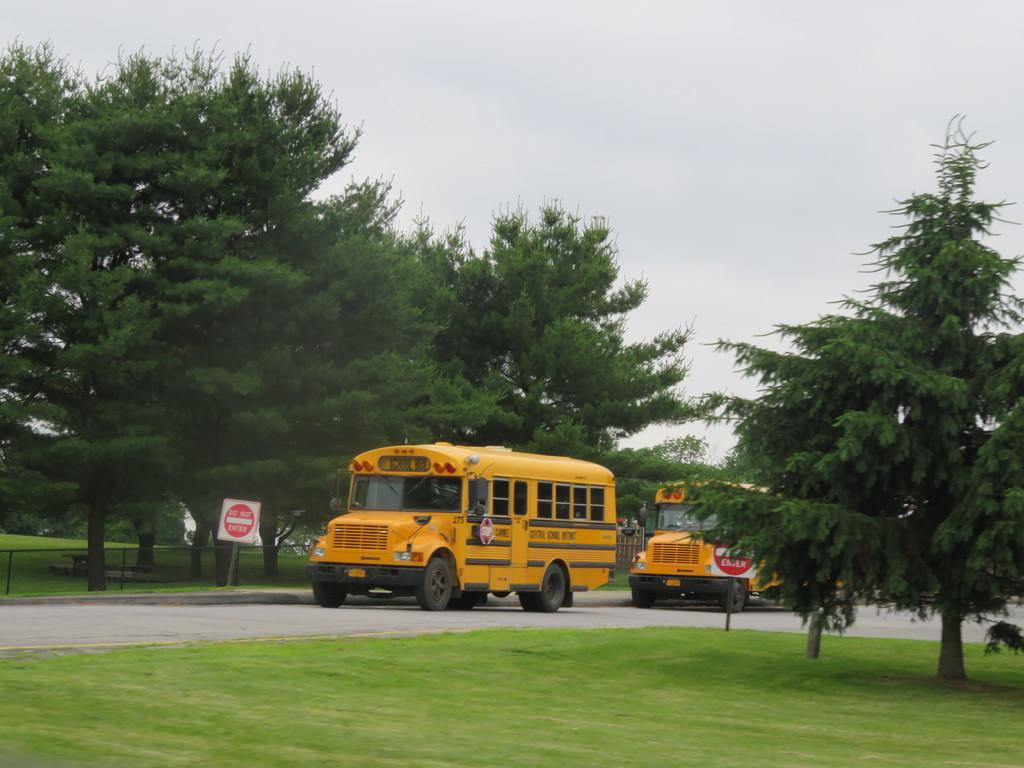What is the main subject in the center of the picture? There are buses, a sign board, trees, a railing, a road, and grass in the center of the picture. Can you describe the sign board in the center of the picture? There is a sign board in the center of the picture, but its content is not visible in the image. What type of vegetation is present in the center of the picture? There are trees and grass in the center of the picture. What is the condition of the sky in the picture? The sky is cloudy in the picture. Can you tell me how many drawers are visible in the picture? There are no drawers present in the picture. What type of crack is visible on the bus in the picture? There are no visible cracks on the bus in the picture. 